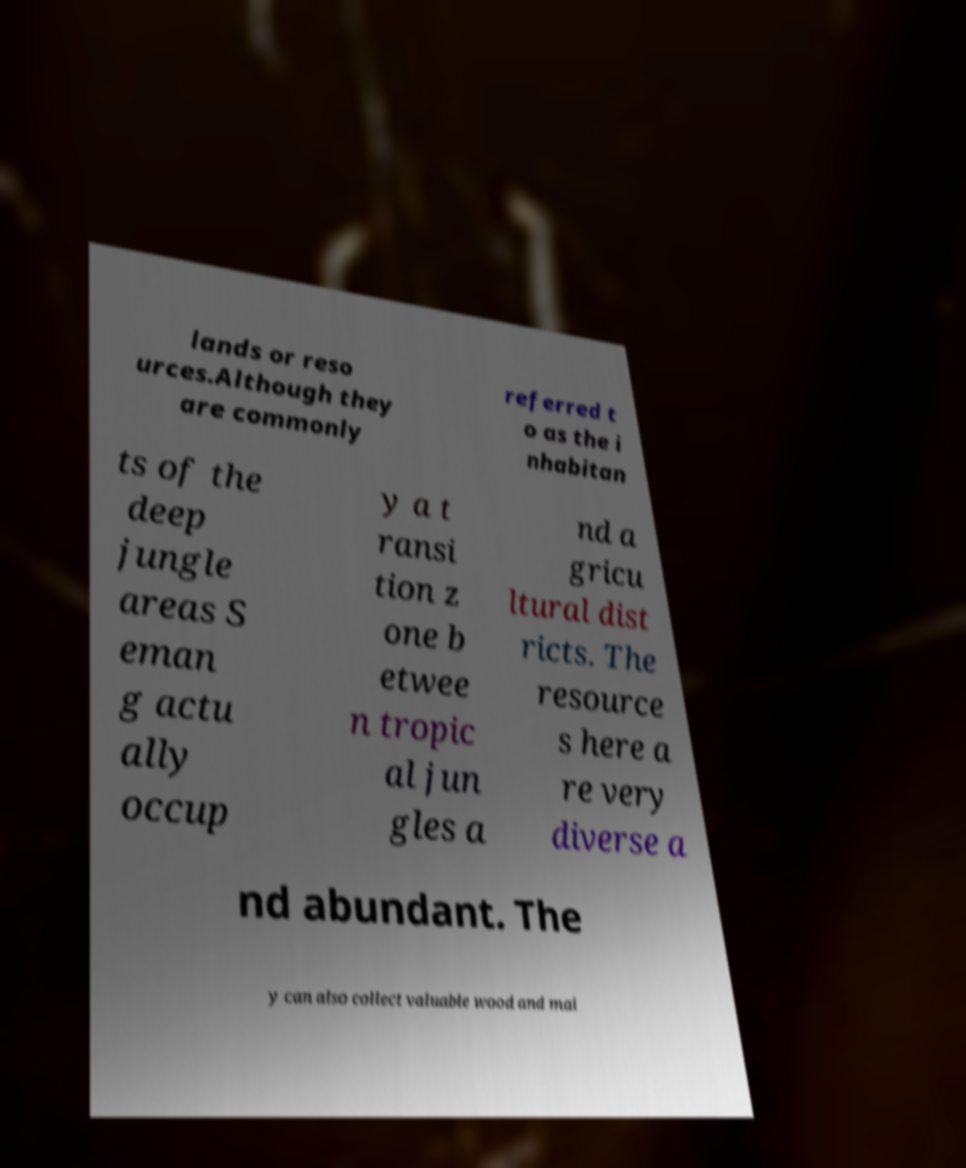Could you extract and type out the text from this image? lands or reso urces.Although they are commonly referred t o as the i nhabitan ts of the deep jungle areas S eman g actu ally occup y a t ransi tion z one b etwee n tropic al jun gles a nd a gricu ltural dist ricts. The resource s here a re very diverse a nd abundant. The y can also collect valuable wood and mai 